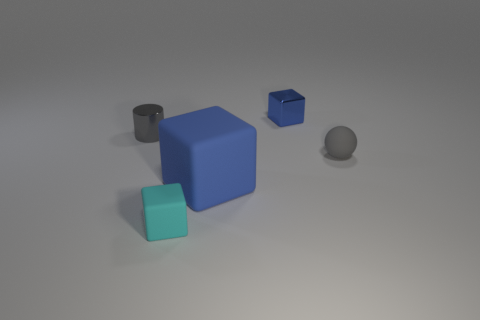What number of other things are the same material as the cylinder?
Give a very brief answer. 1. Does the shiny cylinder have the same size as the object that is to the right of the shiny block?
Your answer should be very brief. Yes. There is a tiny cube in front of the metallic thing that is to the right of the tiny gray cylinder; is there a large blue rubber thing behind it?
Make the answer very short. Yes. There is a tiny block in front of the gray object that is right of the large blue cube; what is it made of?
Provide a succinct answer. Rubber. What is the cube that is both on the right side of the small cyan cube and in front of the small blue thing made of?
Make the answer very short. Rubber. Are there any other small metal objects of the same shape as the small blue thing?
Provide a succinct answer. No. There is a object that is in front of the big matte thing; is there a big block that is on the right side of it?
Your response must be concise. Yes. What number of tiny cyan things have the same material as the tiny blue cube?
Provide a short and direct response. 0. Are there any big green matte things?
Provide a succinct answer. No. How many small objects are the same color as the small sphere?
Offer a terse response. 1. 